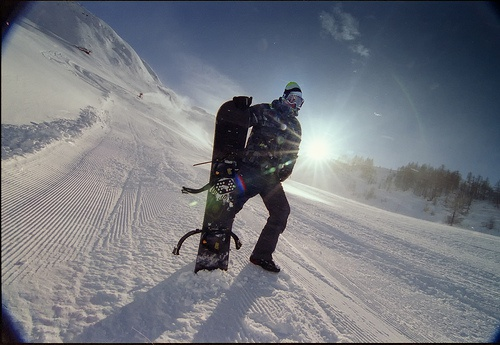Describe the objects in this image and their specific colors. I can see people in black, gray, and darkgray tones and snowboard in black, gray, darkgreen, and darkgray tones in this image. 